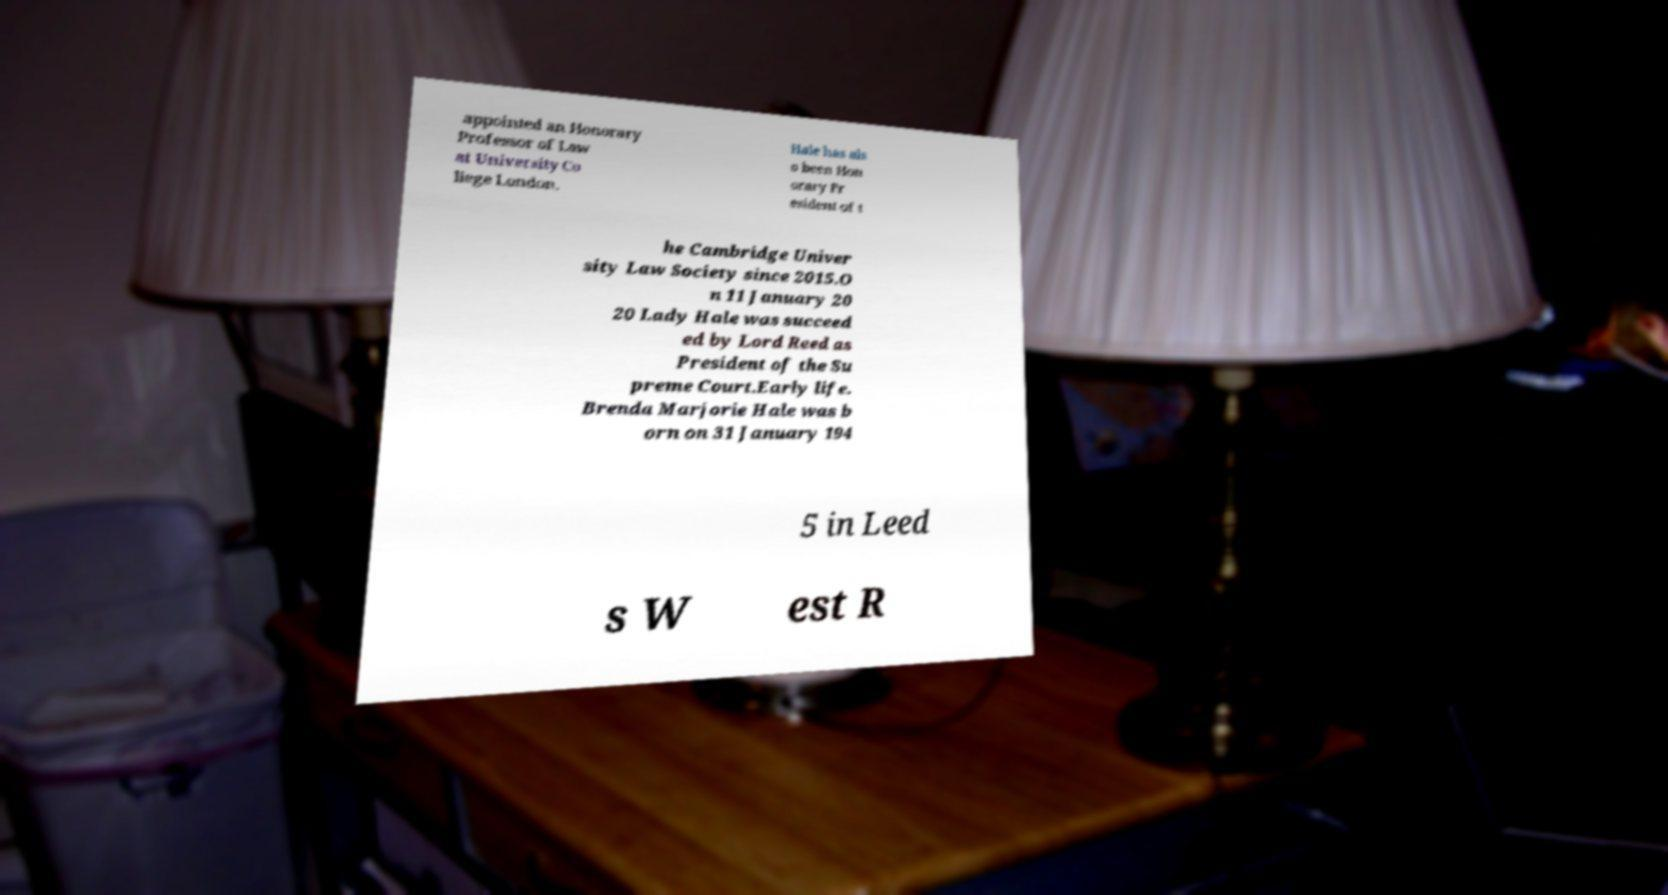Could you extract and type out the text from this image? appointed an Honorary Professor of Law at University Co llege London. Hale has als o been Hon orary Pr esident of t he Cambridge Univer sity Law Society since 2015.O n 11 January 20 20 Lady Hale was succeed ed by Lord Reed as President of the Su preme Court.Early life. Brenda Marjorie Hale was b orn on 31 January 194 5 in Leed s W est R 